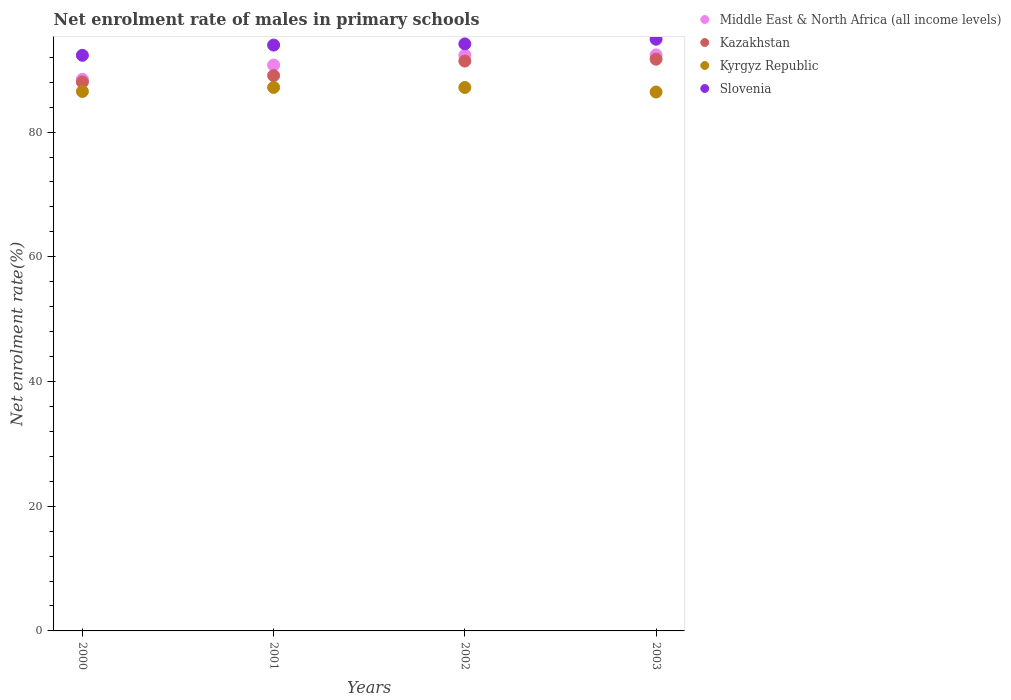What is the net enrolment rate of males in primary schools in Kyrgyz Republic in 2001?
Your answer should be compact. 87.16. Across all years, what is the maximum net enrolment rate of males in primary schools in Middle East & North Africa (all income levels)?
Give a very brief answer. 92.38. Across all years, what is the minimum net enrolment rate of males in primary schools in Kazakhstan?
Your answer should be compact. 88.03. In which year was the net enrolment rate of males in primary schools in Kyrgyz Republic maximum?
Your response must be concise. 2001. In which year was the net enrolment rate of males in primary schools in Kazakhstan minimum?
Keep it short and to the point. 2000. What is the total net enrolment rate of males in primary schools in Kazakhstan in the graph?
Ensure brevity in your answer.  360.18. What is the difference between the net enrolment rate of males in primary schools in Kazakhstan in 2000 and that in 2003?
Provide a succinct answer. -3.66. What is the difference between the net enrolment rate of males in primary schools in Kyrgyz Republic in 2002 and the net enrolment rate of males in primary schools in Kazakhstan in 2001?
Make the answer very short. -1.91. What is the average net enrolment rate of males in primary schools in Kazakhstan per year?
Your response must be concise. 90.04. In the year 2001, what is the difference between the net enrolment rate of males in primary schools in Kazakhstan and net enrolment rate of males in primary schools in Middle East & North Africa (all income levels)?
Make the answer very short. -1.68. In how many years, is the net enrolment rate of males in primary schools in Kazakhstan greater than 24 %?
Your response must be concise. 4. What is the ratio of the net enrolment rate of males in primary schools in Kyrgyz Republic in 2000 to that in 2002?
Provide a short and direct response. 0.99. What is the difference between the highest and the second highest net enrolment rate of males in primary schools in Middle East & North Africa (all income levels)?
Ensure brevity in your answer.  0.05. What is the difference between the highest and the lowest net enrolment rate of males in primary schools in Slovenia?
Provide a short and direct response. 2.58. In how many years, is the net enrolment rate of males in primary schools in Kyrgyz Republic greater than the average net enrolment rate of males in primary schools in Kyrgyz Republic taken over all years?
Make the answer very short. 2. How many dotlines are there?
Provide a succinct answer. 4. How many years are there in the graph?
Provide a succinct answer. 4. Are the values on the major ticks of Y-axis written in scientific E-notation?
Your answer should be compact. No. Where does the legend appear in the graph?
Make the answer very short. Top right. How many legend labels are there?
Keep it short and to the point. 4. How are the legend labels stacked?
Offer a very short reply. Vertical. What is the title of the graph?
Make the answer very short. Net enrolment rate of males in primary schools. What is the label or title of the X-axis?
Your answer should be compact. Years. What is the label or title of the Y-axis?
Offer a very short reply. Net enrolment rate(%). What is the Net enrolment rate(%) in Middle East & North Africa (all income levels) in 2000?
Offer a very short reply. 88.46. What is the Net enrolment rate(%) of Kazakhstan in 2000?
Provide a short and direct response. 88.03. What is the Net enrolment rate(%) in Kyrgyz Republic in 2000?
Your answer should be compact. 86.52. What is the Net enrolment rate(%) in Slovenia in 2000?
Offer a very short reply. 92.31. What is the Net enrolment rate(%) in Middle East & North Africa (all income levels) in 2001?
Ensure brevity in your answer.  90.74. What is the Net enrolment rate(%) in Kazakhstan in 2001?
Your answer should be compact. 89.07. What is the Net enrolment rate(%) of Kyrgyz Republic in 2001?
Your answer should be compact. 87.16. What is the Net enrolment rate(%) in Slovenia in 2001?
Provide a short and direct response. 93.96. What is the Net enrolment rate(%) in Middle East & North Africa (all income levels) in 2002?
Your answer should be compact. 92.33. What is the Net enrolment rate(%) in Kazakhstan in 2002?
Ensure brevity in your answer.  91.39. What is the Net enrolment rate(%) of Kyrgyz Republic in 2002?
Your response must be concise. 87.15. What is the Net enrolment rate(%) of Slovenia in 2002?
Your answer should be very brief. 94.14. What is the Net enrolment rate(%) in Middle East & North Africa (all income levels) in 2003?
Keep it short and to the point. 92.38. What is the Net enrolment rate(%) of Kazakhstan in 2003?
Provide a succinct answer. 91.69. What is the Net enrolment rate(%) of Kyrgyz Republic in 2003?
Your answer should be compact. 86.42. What is the Net enrolment rate(%) of Slovenia in 2003?
Your answer should be very brief. 94.89. Across all years, what is the maximum Net enrolment rate(%) of Middle East & North Africa (all income levels)?
Provide a succinct answer. 92.38. Across all years, what is the maximum Net enrolment rate(%) in Kazakhstan?
Your answer should be compact. 91.69. Across all years, what is the maximum Net enrolment rate(%) of Kyrgyz Republic?
Offer a terse response. 87.16. Across all years, what is the maximum Net enrolment rate(%) of Slovenia?
Offer a very short reply. 94.89. Across all years, what is the minimum Net enrolment rate(%) in Middle East & North Africa (all income levels)?
Ensure brevity in your answer.  88.46. Across all years, what is the minimum Net enrolment rate(%) in Kazakhstan?
Your answer should be very brief. 88.03. Across all years, what is the minimum Net enrolment rate(%) in Kyrgyz Republic?
Give a very brief answer. 86.42. Across all years, what is the minimum Net enrolment rate(%) in Slovenia?
Your answer should be compact. 92.31. What is the total Net enrolment rate(%) of Middle East & North Africa (all income levels) in the graph?
Provide a succinct answer. 363.9. What is the total Net enrolment rate(%) of Kazakhstan in the graph?
Offer a very short reply. 360.18. What is the total Net enrolment rate(%) of Kyrgyz Republic in the graph?
Your answer should be very brief. 347.26. What is the total Net enrolment rate(%) in Slovenia in the graph?
Offer a terse response. 375.31. What is the difference between the Net enrolment rate(%) of Middle East & North Africa (all income levels) in 2000 and that in 2001?
Make the answer very short. -2.29. What is the difference between the Net enrolment rate(%) in Kazakhstan in 2000 and that in 2001?
Your answer should be compact. -1.03. What is the difference between the Net enrolment rate(%) in Kyrgyz Republic in 2000 and that in 2001?
Your response must be concise. -0.64. What is the difference between the Net enrolment rate(%) of Slovenia in 2000 and that in 2001?
Ensure brevity in your answer.  -1.64. What is the difference between the Net enrolment rate(%) in Middle East & North Africa (all income levels) in 2000 and that in 2002?
Give a very brief answer. -3.87. What is the difference between the Net enrolment rate(%) of Kazakhstan in 2000 and that in 2002?
Provide a short and direct response. -3.36. What is the difference between the Net enrolment rate(%) of Kyrgyz Republic in 2000 and that in 2002?
Provide a short and direct response. -0.63. What is the difference between the Net enrolment rate(%) in Slovenia in 2000 and that in 2002?
Make the answer very short. -1.83. What is the difference between the Net enrolment rate(%) in Middle East & North Africa (all income levels) in 2000 and that in 2003?
Your answer should be very brief. -3.92. What is the difference between the Net enrolment rate(%) in Kazakhstan in 2000 and that in 2003?
Offer a terse response. -3.66. What is the difference between the Net enrolment rate(%) in Kyrgyz Republic in 2000 and that in 2003?
Provide a short and direct response. 0.1. What is the difference between the Net enrolment rate(%) in Slovenia in 2000 and that in 2003?
Keep it short and to the point. -2.58. What is the difference between the Net enrolment rate(%) of Middle East & North Africa (all income levels) in 2001 and that in 2002?
Provide a short and direct response. -1.58. What is the difference between the Net enrolment rate(%) in Kazakhstan in 2001 and that in 2002?
Make the answer very short. -2.33. What is the difference between the Net enrolment rate(%) of Kyrgyz Republic in 2001 and that in 2002?
Ensure brevity in your answer.  0.01. What is the difference between the Net enrolment rate(%) of Slovenia in 2001 and that in 2002?
Make the answer very short. -0.19. What is the difference between the Net enrolment rate(%) in Middle East & North Africa (all income levels) in 2001 and that in 2003?
Give a very brief answer. -1.63. What is the difference between the Net enrolment rate(%) of Kazakhstan in 2001 and that in 2003?
Make the answer very short. -2.63. What is the difference between the Net enrolment rate(%) of Kyrgyz Republic in 2001 and that in 2003?
Offer a terse response. 0.74. What is the difference between the Net enrolment rate(%) in Slovenia in 2001 and that in 2003?
Your response must be concise. -0.94. What is the difference between the Net enrolment rate(%) in Middle East & North Africa (all income levels) in 2002 and that in 2003?
Provide a succinct answer. -0.05. What is the difference between the Net enrolment rate(%) of Kazakhstan in 2002 and that in 2003?
Keep it short and to the point. -0.3. What is the difference between the Net enrolment rate(%) of Kyrgyz Republic in 2002 and that in 2003?
Provide a succinct answer. 0.73. What is the difference between the Net enrolment rate(%) of Slovenia in 2002 and that in 2003?
Your answer should be compact. -0.75. What is the difference between the Net enrolment rate(%) of Middle East & North Africa (all income levels) in 2000 and the Net enrolment rate(%) of Kazakhstan in 2001?
Keep it short and to the point. -0.61. What is the difference between the Net enrolment rate(%) in Middle East & North Africa (all income levels) in 2000 and the Net enrolment rate(%) in Kyrgyz Republic in 2001?
Provide a succinct answer. 1.29. What is the difference between the Net enrolment rate(%) of Middle East & North Africa (all income levels) in 2000 and the Net enrolment rate(%) of Slovenia in 2001?
Offer a terse response. -5.5. What is the difference between the Net enrolment rate(%) of Kazakhstan in 2000 and the Net enrolment rate(%) of Kyrgyz Republic in 2001?
Give a very brief answer. 0.87. What is the difference between the Net enrolment rate(%) in Kazakhstan in 2000 and the Net enrolment rate(%) in Slovenia in 2001?
Offer a terse response. -5.92. What is the difference between the Net enrolment rate(%) of Kyrgyz Republic in 2000 and the Net enrolment rate(%) of Slovenia in 2001?
Your answer should be very brief. -7.43. What is the difference between the Net enrolment rate(%) in Middle East & North Africa (all income levels) in 2000 and the Net enrolment rate(%) in Kazakhstan in 2002?
Provide a short and direct response. -2.94. What is the difference between the Net enrolment rate(%) of Middle East & North Africa (all income levels) in 2000 and the Net enrolment rate(%) of Kyrgyz Republic in 2002?
Offer a very short reply. 1.3. What is the difference between the Net enrolment rate(%) of Middle East & North Africa (all income levels) in 2000 and the Net enrolment rate(%) of Slovenia in 2002?
Offer a terse response. -5.69. What is the difference between the Net enrolment rate(%) in Kazakhstan in 2000 and the Net enrolment rate(%) in Kyrgyz Republic in 2002?
Provide a succinct answer. 0.88. What is the difference between the Net enrolment rate(%) of Kazakhstan in 2000 and the Net enrolment rate(%) of Slovenia in 2002?
Make the answer very short. -6.11. What is the difference between the Net enrolment rate(%) in Kyrgyz Republic in 2000 and the Net enrolment rate(%) in Slovenia in 2002?
Your response must be concise. -7.62. What is the difference between the Net enrolment rate(%) in Middle East & North Africa (all income levels) in 2000 and the Net enrolment rate(%) in Kazakhstan in 2003?
Offer a terse response. -3.23. What is the difference between the Net enrolment rate(%) of Middle East & North Africa (all income levels) in 2000 and the Net enrolment rate(%) of Kyrgyz Republic in 2003?
Provide a succinct answer. 2.03. What is the difference between the Net enrolment rate(%) in Middle East & North Africa (all income levels) in 2000 and the Net enrolment rate(%) in Slovenia in 2003?
Your response must be concise. -6.44. What is the difference between the Net enrolment rate(%) of Kazakhstan in 2000 and the Net enrolment rate(%) of Kyrgyz Republic in 2003?
Your answer should be compact. 1.61. What is the difference between the Net enrolment rate(%) in Kazakhstan in 2000 and the Net enrolment rate(%) in Slovenia in 2003?
Offer a very short reply. -6.86. What is the difference between the Net enrolment rate(%) of Kyrgyz Republic in 2000 and the Net enrolment rate(%) of Slovenia in 2003?
Provide a succinct answer. -8.37. What is the difference between the Net enrolment rate(%) in Middle East & North Africa (all income levels) in 2001 and the Net enrolment rate(%) in Kazakhstan in 2002?
Your answer should be compact. -0.65. What is the difference between the Net enrolment rate(%) in Middle East & North Africa (all income levels) in 2001 and the Net enrolment rate(%) in Kyrgyz Republic in 2002?
Your answer should be very brief. 3.59. What is the difference between the Net enrolment rate(%) of Middle East & North Africa (all income levels) in 2001 and the Net enrolment rate(%) of Slovenia in 2002?
Offer a very short reply. -3.4. What is the difference between the Net enrolment rate(%) of Kazakhstan in 2001 and the Net enrolment rate(%) of Kyrgyz Republic in 2002?
Your response must be concise. 1.91. What is the difference between the Net enrolment rate(%) in Kazakhstan in 2001 and the Net enrolment rate(%) in Slovenia in 2002?
Your answer should be very brief. -5.08. What is the difference between the Net enrolment rate(%) of Kyrgyz Republic in 2001 and the Net enrolment rate(%) of Slovenia in 2002?
Your response must be concise. -6.98. What is the difference between the Net enrolment rate(%) in Middle East & North Africa (all income levels) in 2001 and the Net enrolment rate(%) in Kazakhstan in 2003?
Make the answer very short. -0.95. What is the difference between the Net enrolment rate(%) in Middle East & North Africa (all income levels) in 2001 and the Net enrolment rate(%) in Kyrgyz Republic in 2003?
Give a very brief answer. 4.32. What is the difference between the Net enrolment rate(%) in Middle East & North Africa (all income levels) in 2001 and the Net enrolment rate(%) in Slovenia in 2003?
Offer a terse response. -4.15. What is the difference between the Net enrolment rate(%) of Kazakhstan in 2001 and the Net enrolment rate(%) of Kyrgyz Republic in 2003?
Your answer should be compact. 2.64. What is the difference between the Net enrolment rate(%) in Kazakhstan in 2001 and the Net enrolment rate(%) in Slovenia in 2003?
Ensure brevity in your answer.  -5.83. What is the difference between the Net enrolment rate(%) in Kyrgyz Republic in 2001 and the Net enrolment rate(%) in Slovenia in 2003?
Offer a terse response. -7.73. What is the difference between the Net enrolment rate(%) of Middle East & North Africa (all income levels) in 2002 and the Net enrolment rate(%) of Kazakhstan in 2003?
Your response must be concise. 0.63. What is the difference between the Net enrolment rate(%) in Middle East & North Africa (all income levels) in 2002 and the Net enrolment rate(%) in Kyrgyz Republic in 2003?
Keep it short and to the point. 5.9. What is the difference between the Net enrolment rate(%) of Middle East & North Africa (all income levels) in 2002 and the Net enrolment rate(%) of Slovenia in 2003?
Keep it short and to the point. -2.57. What is the difference between the Net enrolment rate(%) in Kazakhstan in 2002 and the Net enrolment rate(%) in Kyrgyz Republic in 2003?
Keep it short and to the point. 4.97. What is the difference between the Net enrolment rate(%) of Kazakhstan in 2002 and the Net enrolment rate(%) of Slovenia in 2003?
Keep it short and to the point. -3.5. What is the difference between the Net enrolment rate(%) in Kyrgyz Republic in 2002 and the Net enrolment rate(%) in Slovenia in 2003?
Make the answer very short. -7.74. What is the average Net enrolment rate(%) of Middle East & North Africa (all income levels) per year?
Ensure brevity in your answer.  90.98. What is the average Net enrolment rate(%) of Kazakhstan per year?
Offer a very short reply. 90.05. What is the average Net enrolment rate(%) of Kyrgyz Republic per year?
Your response must be concise. 86.82. What is the average Net enrolment rate(%) in Slovenia per year?
Ensure brevity in your answer.  93.83. In the year 2000, what is the difference between the Net enrolment rate(%) in Middle East & North Africa (all income levels) and Net enrolment rate(%) in Kazakhstan?
Offer a terse response. 0.43. In the year 2000, what is the difference between the Net enrolment rate(%) in Middle East & North Africa (all income levels) and Net enrolment rate(%) in Kyrgyz Republic?
Give a very brief answer. 1.94. In the year 2000, what is the difference between the Net enrolment rate(%) of Middle East & North Africa (all income levels) and Net enrolment rate(%) of Slovenia?
Offer a very short reply. -3.86. In the year 2000, what is the difference between the Net enrolment rate(%) of Kazakhstan and Net enrolment rate(%) of Kyrgyz Republic?
Offer a very short reply. 1.51. In the year 2000, what is the difference between the Net enrolment rate(%) of Kazakhstan and Net enrolment rate(%) of Slovenia?
Offer a terse response. -4.28. In the year 2000, what is the difference between the Net enrolment rate(%) in Kyrgyz Republic and Net enrolment rate(%) in Slovenia?
Offer a very short reply. -5.79. In the year 2001, what is the difference between the Net enrolment rate(%) of Middle East & North Africa (all income levels) and Net enrolment rate(%) of Kazakhstan?
Provide a short and direct response. 1.68. In the year 2001, what is the difference between the Net enrolment rate(%) of Middle East & North Africa (all income levels) and Net enrolment rate(%) of Kyrgyz Republic?
Make the answer very short. 3.58. In the year 2001, what is the difference between the Net enrolment rate(%) of Middle East & North Africa (all income levels) and Net enrolment rate(%) of Slovenia?
Ensure brevity in your answer.  -3.21. In the year 2001, what is the difference between the Net enrolment rate(%) of Kazakhstan and Net enrolment rate(%) of Kyrgyz Republic?
Make the answer very short. 1.9. In the year 2001, what is the difference between the Net enrolment rate(%) of Kazakhstan and Net enrolment rate(%) of Slovenia?
Your answer should be very brief. -4.89. In the year 2001, what is the difference between the Net enrolment rate(%) of Kyrgyz Republic and Net enrolment rate(%) of Slovenia?
Provide a short and direct response. -6.79. In the year 2002, what is the difference between the Net enrolment rate(%) of Middle East & North Africa (all income levels) and Net enrolment rate(%) of Kazakhstan?
Offer a very short reply. 0.93. In the year 2002, what is the difference between the Net enrolment rate(%) in Middle East & North Africa (all income levels) and Net enrolment rate(%) in Kyrgyz Republic?
Give a very brief answer. 5.17. In the year 2002, what is the difference between the Net enrolment rate(%) of Middle East & North Africa (all income levels) and Net enrolment rate(%) of Slovenia?
Provide a short and direct response. -1.82. In the year 2002, what is the difference between the Net enrolment rate(%) in Kazakhstan and Net enrolment rate(%) in Kyrgyz Republic?
Offer a terse response. 4.24. In the year 2002, what is the difference between the Net enrolment rate(%) of Kazakhstan and Net enrolment rate(%) of Slovenia?
Your response must be concise. -2.75. In the year 2002, what is the difference between the Net enrolment rate(%) in Kyrgyz Republic and Net enrolment rate(%) in Slovenia?
Provide a short and direct response. -6.99. In the year 2003, what is the difference between the Net enrolment rate(%) of Middle East & North Africa (all income levels) and Net enrolment rate(%) of Kazakhstan?
Your answer should be compact. 0.69. In the year 2003, what is the difference between the Net enrolment rate(%) in Middle East & North Africa (all income levels) and Net enrolment rate(%) in Kyrgyz Republic?
Offer a very short reply. 5.95. In the year 2003, what is the difference between the Net enrolment rate(%) in Middle East & North Africa (all income levels) and Net enrolment rate(%) in Slovenia?
Provide a succinct answer. -2.52. In the year 2003, what is the difference between the Net enrolment rate(%) of Kazakhstan and Net enrolment rate(%) of Kyrgyz Republic?
Your response must be concise. 5.27. In the year 2003, what is the difference between the Net enrolment rate(%) in Kazakhstan and Net enrolment rate(%) in Slovenia?
Your answer should be compact. -3.2. In the year 2003, what is the difference between the Net enrolment rate(%) in Kyrgyz Republic and Net enrolment rate(%) in Slovenia?
Give a very brief answer. -8.47. What is the ratio of the Net enrolment rate(%) of Middle East & North Africa (all income levels) in 2000 to that in 2001?
Provide a short and direct response. 0.97. What is the ratio of the Net enrolment rate(%) in Kazakhstan in 2000 to that in 2001?
Provide a short and direct response. 0.99. What is the ratio of the Net enrolment rate(%) in Kyrgyz Republic in 2000 to that in 2001?
Offer a terse response. 0.99. What is the ratio of the Net enrolment rate(%) in Slovenia in 2000 to that in 2001?
Keep it short and to the point. 0.98. What is the ratio of the Net enrolment rate(%) in Middle East & North Africa (all income levels) in 2000 to that in 2002?
Your response must be concise. 0.96. What is the ratio of the Net enrolment rate(%) in Kazakhstan in 2000 to that in 2002?
Provide a short and direct response. 0.96. What is the ratio of the Net enrolment rate(%) in Slovenia in 2000 to that in 2002?
Offer a very short reply. 0.98. What is the ratio of the Net enrolment rate(%) in Middle East & North Africa (all income levels) in 2000 to that in 2003?
Offer a very short reply. 0.96. What is the ratio of the Net enrolment rate(%) of Kazakhstan in 2000 to that in 2003?
Ensure brevity in your answer.  0.96. What is the ratio of the Net enrolment rate(%) of Slovenia in 2000 to that in 2003?
Your response must be concise. 0.97. What is the ratio of the Net enrolment rate(%) in Middle East & North Africa (all income levels) in 2001 to that in 2002?
Keep it short and to the point. 0.98. What is the ratio of the Net enrolment rate(%) of Kazakhstan in 2001 to that in 2002?
Ensure brevity in your answer.  0.97. What is the ratio of the Net enrolment rate(%) of Slovenia in 2001 to that in 2002?
Your response must be concise. 1. What is the ratio of the Net enrolment rate(%) in Middle East & North Africa (all income levels) in 2001 to that in 2003?
Offer a terse response. 0.98. What is the ratio of the Net enrolment rate(%) of Kazakhstan in 2001 to that in 2003?
Keep it short and to the point. 0.97. What is the ratio of the Net enrolment rate(%) of Kyrgyz Republic in 2001 to that in 2003?
Provide a succinct answer. 1.01. What is the ratio of the Net enrolment rate(%) of Slovenia in 2001 to that in 2003?
Provide a short and direct response. 0.99. What is the ratio of the Net enrolment rate(%) of Middle East & North Africa (all income levels) in 2002 to that in 2003?
Your answer should be very brief. 1. What is the ratio of the Net enrolment rate(%) in Kyrgyz Republic in 2002 to that in 2003?
Your response must be concise. 1.01. What is the ratio of the Net enrolment rate(%) of Slovenia in 2002 to that in 2003?
Provide a succinct answer. 0.99. What is the difference between the highest and the second highest Net enrolment rate(%) in Middle East & North Africa (all income levels)?
Your response must be concise. 0.05. What is the difference between the highest and the second highest Net enrolment rate(%) in Kazakhstan?
Provide a short and direct response. 0.3. What is the difference between the highest and the second highest Net enrolment rate(%) of Kyrgyz Republic?
Your answer should be compact. 0.01. What is the difference between the highest and the second highest Net enrolment rate(%) in Slovenia?
Keep it short and to the point. 0.75. What is the difference between the highest and the lowest Net enrolment rate(%) in Middle East & North Africa (all income levels)?
Ensure brevity in your answer.  3.92. What is the difference between the highest and the lowest Net enrolment rate(%) in Kazakhstan?
Give a very brief answer. 3.66. What is the difference between the highest and the lowest Net enrolment rate(%) of Kyrgyz Republic?
Give a very brief answer. 0.74. What is the difference between the highest and the lowest Net enrolment rate(%) in Slovenia?
Provide a short and direct response. 2.58. 